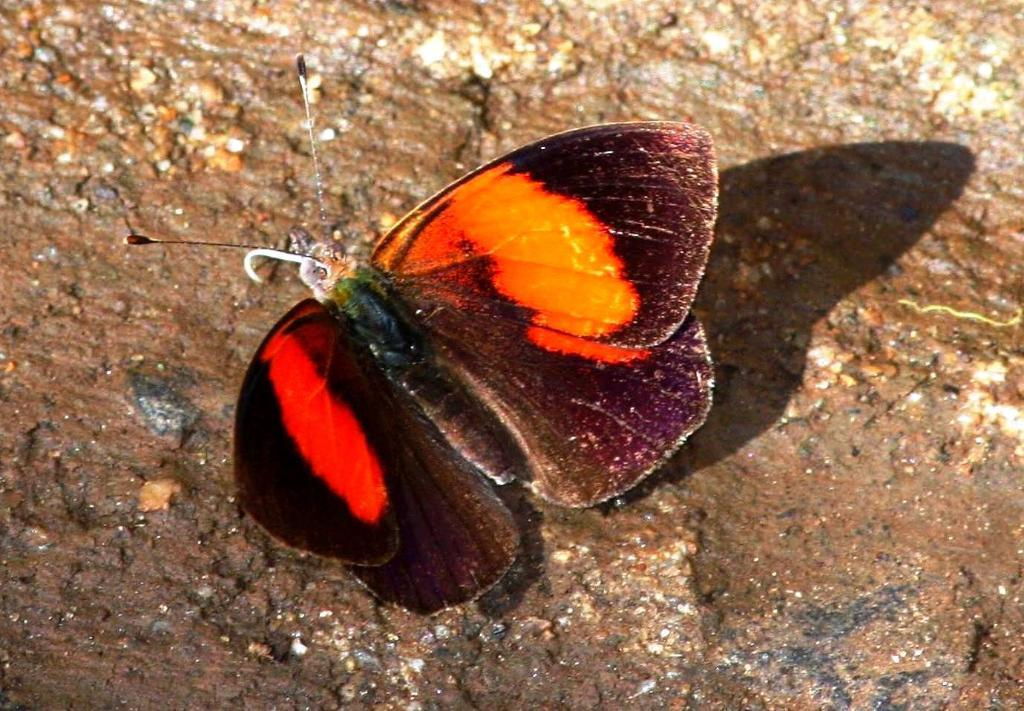What type of insect is present in the image? There is a butterfly in the image. Where is the butterfly located in the image? The butterfly is on the floor. What type of quilt is being offered to the butterfly in the image? There is no quilt present in the image, nor is there any indication of an offer being made to the butterfly. 